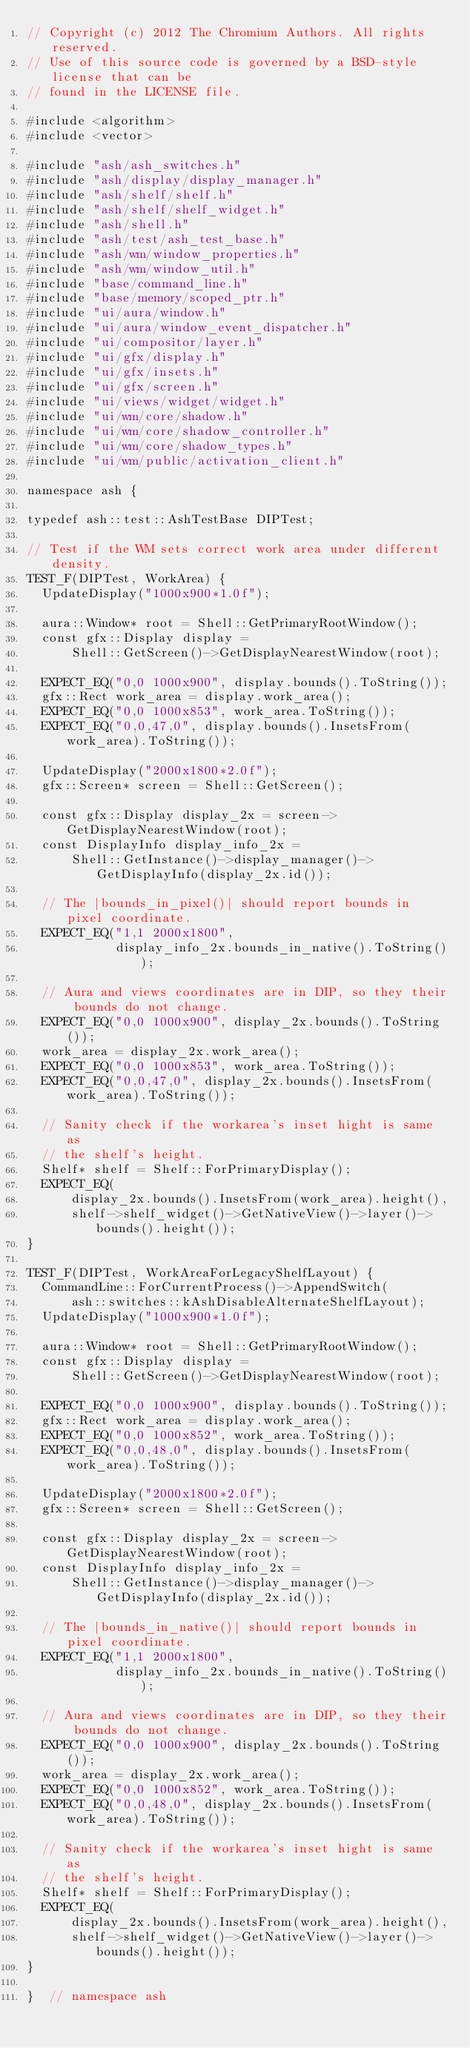Convert code to text. <code><loc_0><loc_0><loc_500><loc_500><_C++_>// Copyright (c) 2012 The Chromium Authors. All rights reserved.
// Use of this source code is governed by a BSD-style license that can be
// found in the LICENSE file.

#include <algorithm>
#include <vector>

#include "ash/ash_switches.h"
#include "ash/display/display_manager.h"
#include "ash/shelf/shelf.h"
#include "ash/shelf/shelf_widget.h"
#include "ash/shell.h"
#include "ash/test/ash_test_base.h"
#include "ash/wm/window_properties.h"
#include "ash/wm/window_util.h"
#include "base/command_line.h"
#include "base/memory/scoped_ptr.h"
#include "ui/aura/window.h"
#include "ui/aura/window_event_dispatcher.h"
#include "ui/compositor/layer.h"
#include "ui/gfx/display.h"
#include "ui/gfx/insets.h"
#include "ui/gfx/screen.h"
#include "ui/views/widget/widget.h"
#include "ui/wm/core/shadow.h"
#include "ui/wm/core/shadow_controller.h"
#include "ui/wm/core/shadow_types.h"
#include "ui/wm/public/activation_client.h"

namespace ash {

typedef ash::test::AshTestBase DIPTest;

// Test if the WM sets correct work area under different density.
TEST_F(DIPTest, WorkArea) {
  UpdateDisplay("1000x900*1.0f");

  aura::Window* root = Shell::GetPrimaryRootWindow();
  const gfx::Display display =
      Shell::GetScreen()->GetDisplayNearestWindow(root);

  EXPECT_EQ("0,0 1000x900", display.bounds().ToString());
  gfx::Rect work_area = display.work_area();
  EXPECT_EQ("0,0 1000x853", work_area.ToString());
  EXPECT_EQ("0,0,47,0", display.bounds().InsetsFrom(work_area).ToString());

  UpdateDisplay("2000x1800*2.0f");
  gfx::Screen* screen = Shell::GetScreen();

  const gfx::Display display_2x = screen->GetDisplayNearestWindow(root);
  const DisplayInfo display_info_2x =
      Shell::GetInstance()->display_manager()->GetDisplayInfo(display_2x.id());

  // The |bounds_in_pixel()| should report bounds in pixel coordinate.
  EXPECT_EQ("1,1 2000x1800",
            display_info_2x.bounds_in_native().ToString());

  // Aura and views coordinates are in DIP, so they their bounds do not change.
  EXPECT_EQ("0,0 1000x900", display_2x.bounds().ToString());
  work_area = display_2x.work_area();
  EXPECT_EQ("0,0 1000x853", work_area.ToString());
  EXPECT_EQ("0,0,47,0", display_2x.bounds().InsetsFrom(work_area).ToString());

  // Sanity check if the workarea's inset hight is same as
  // the shelf's height.
  Shelf* shelf = Shelf::ForPrimaryDisplay();
  EXPECT_EQ(
      display_2x.bounds().InsetsFrom(work_area).height(),
      shelf->shelf_widget()->GetNativeView()->layer()->bounds().height());
}

TEST_F(DIPTest, WorkAreaForLegacyShelfLayout) {
  CommandLine::ForCurrentProcess()->AppendSwitch(
      ash::switches::kAshDisableAlternateShelfLayout);
  UpdateDisplay("1000x900*1.0f");

  aura::Window* root = Shell::GetPrimaryRootWindow();
  const gfx::Display display =
      Shell::GetScreen()->GetDisplayNearestWindow(root);

  EXPECT_EQ("0,0 1000x900", display.bounds().ToString());
  gfx::Rect work_area = display.work_area();
  EXPECT_EQ("0,0 1000x852", work_area.ToString());
  EXPECT_EQ("0,0,48,0", display.bounds().InsetsFrom(work_area).ToString());

  UpdateDisplay("2000x1800*2.0f");
  gfx::Screen* screen = Shell::GetScreen();

  const gfx::Display display_2x = screen->GetDisplayNearestWindow(root);
  const DisplayInfo display_info_2x =
      Shell::GetInstance()->display_manager()->GetDisplayInfo(display_2x.id());

  // The |bounds_in_native()| should report bounds in pixel coordinate.
  EXPECT_EQ("1,1 2000x1800",
            display_info_2x.bounds_in_native().ToString());

  // Aura and views coordinates are in DIP, so they their bounds do not change.
  EXPECT_EQ("0,0 1000x900", display_2x.bounds().ToString());
  work_area = display_2x.work_area();
  EXPECT_EQ("0,0 1000x852", work_area.ToString());
  EXPECT_EQ("0,0,48,0", display_2x.bounds().InsetsFrom(work_area).ToString());

  // Sanity check if the workarea's inset hight is same as
  // the shelf's height.
  Shelf* shelf = Shelf::ForPrimaryDisplay();
  EXPECT_EQ(
      display_2x.bounds().InsetsFrom(work_area).height(),
      shelf->shelf_widget()->GetNativeView()->layer()->bounds().height());
}

}  // namespace ash
</code> 